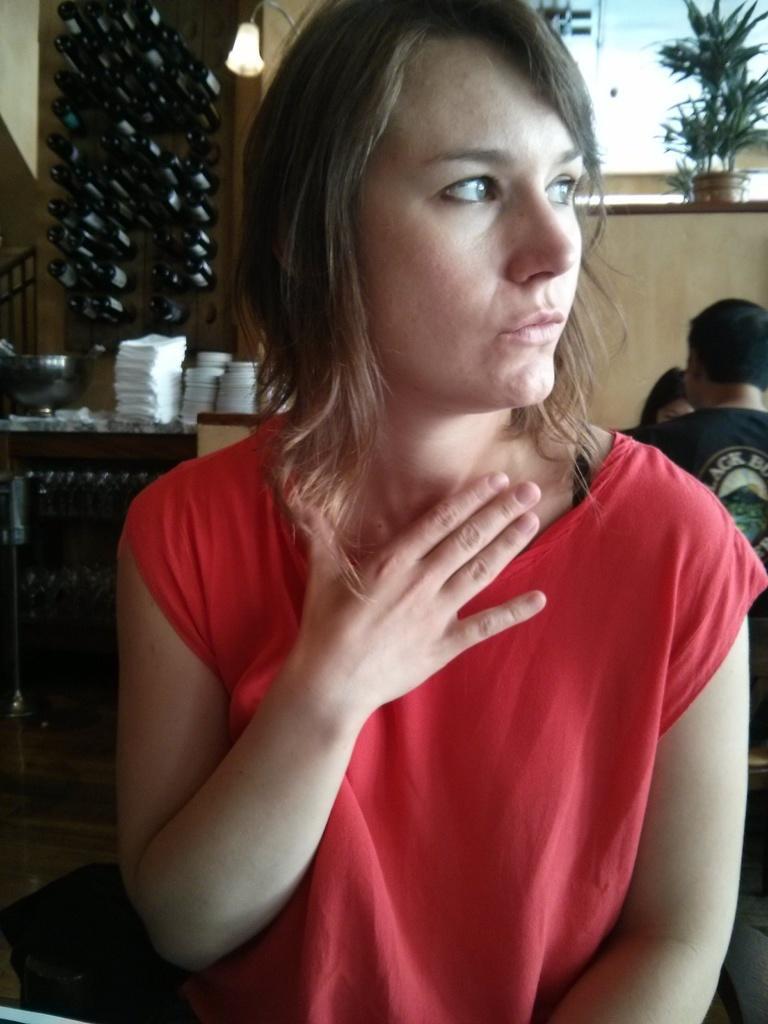Describe this image in one or two sentences. In front of the image there is a lady. Behind the lady there are two persons. On the left side of the image there is a table with bowls, tissues and some other things. Behind the table there are bottles. On the right side of the image there is a potted plant. 